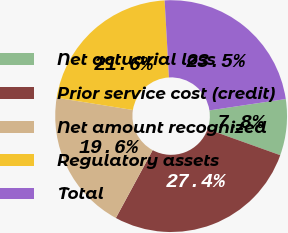Convert chart to OTSL. <chart><loc_0><loc_0><loc_500><loc_500><pie_chart><fcel>Net actuarial loss<fcel>Prior service cost (credit)<fcel>Net amount recognized<fcel>Regulatory assets<fcel>Total<nl><fcel>7.83%<fcel>27.44%<fcel>19.62%<fcel>21.58%<fcel>23.54%<nl></chart> 